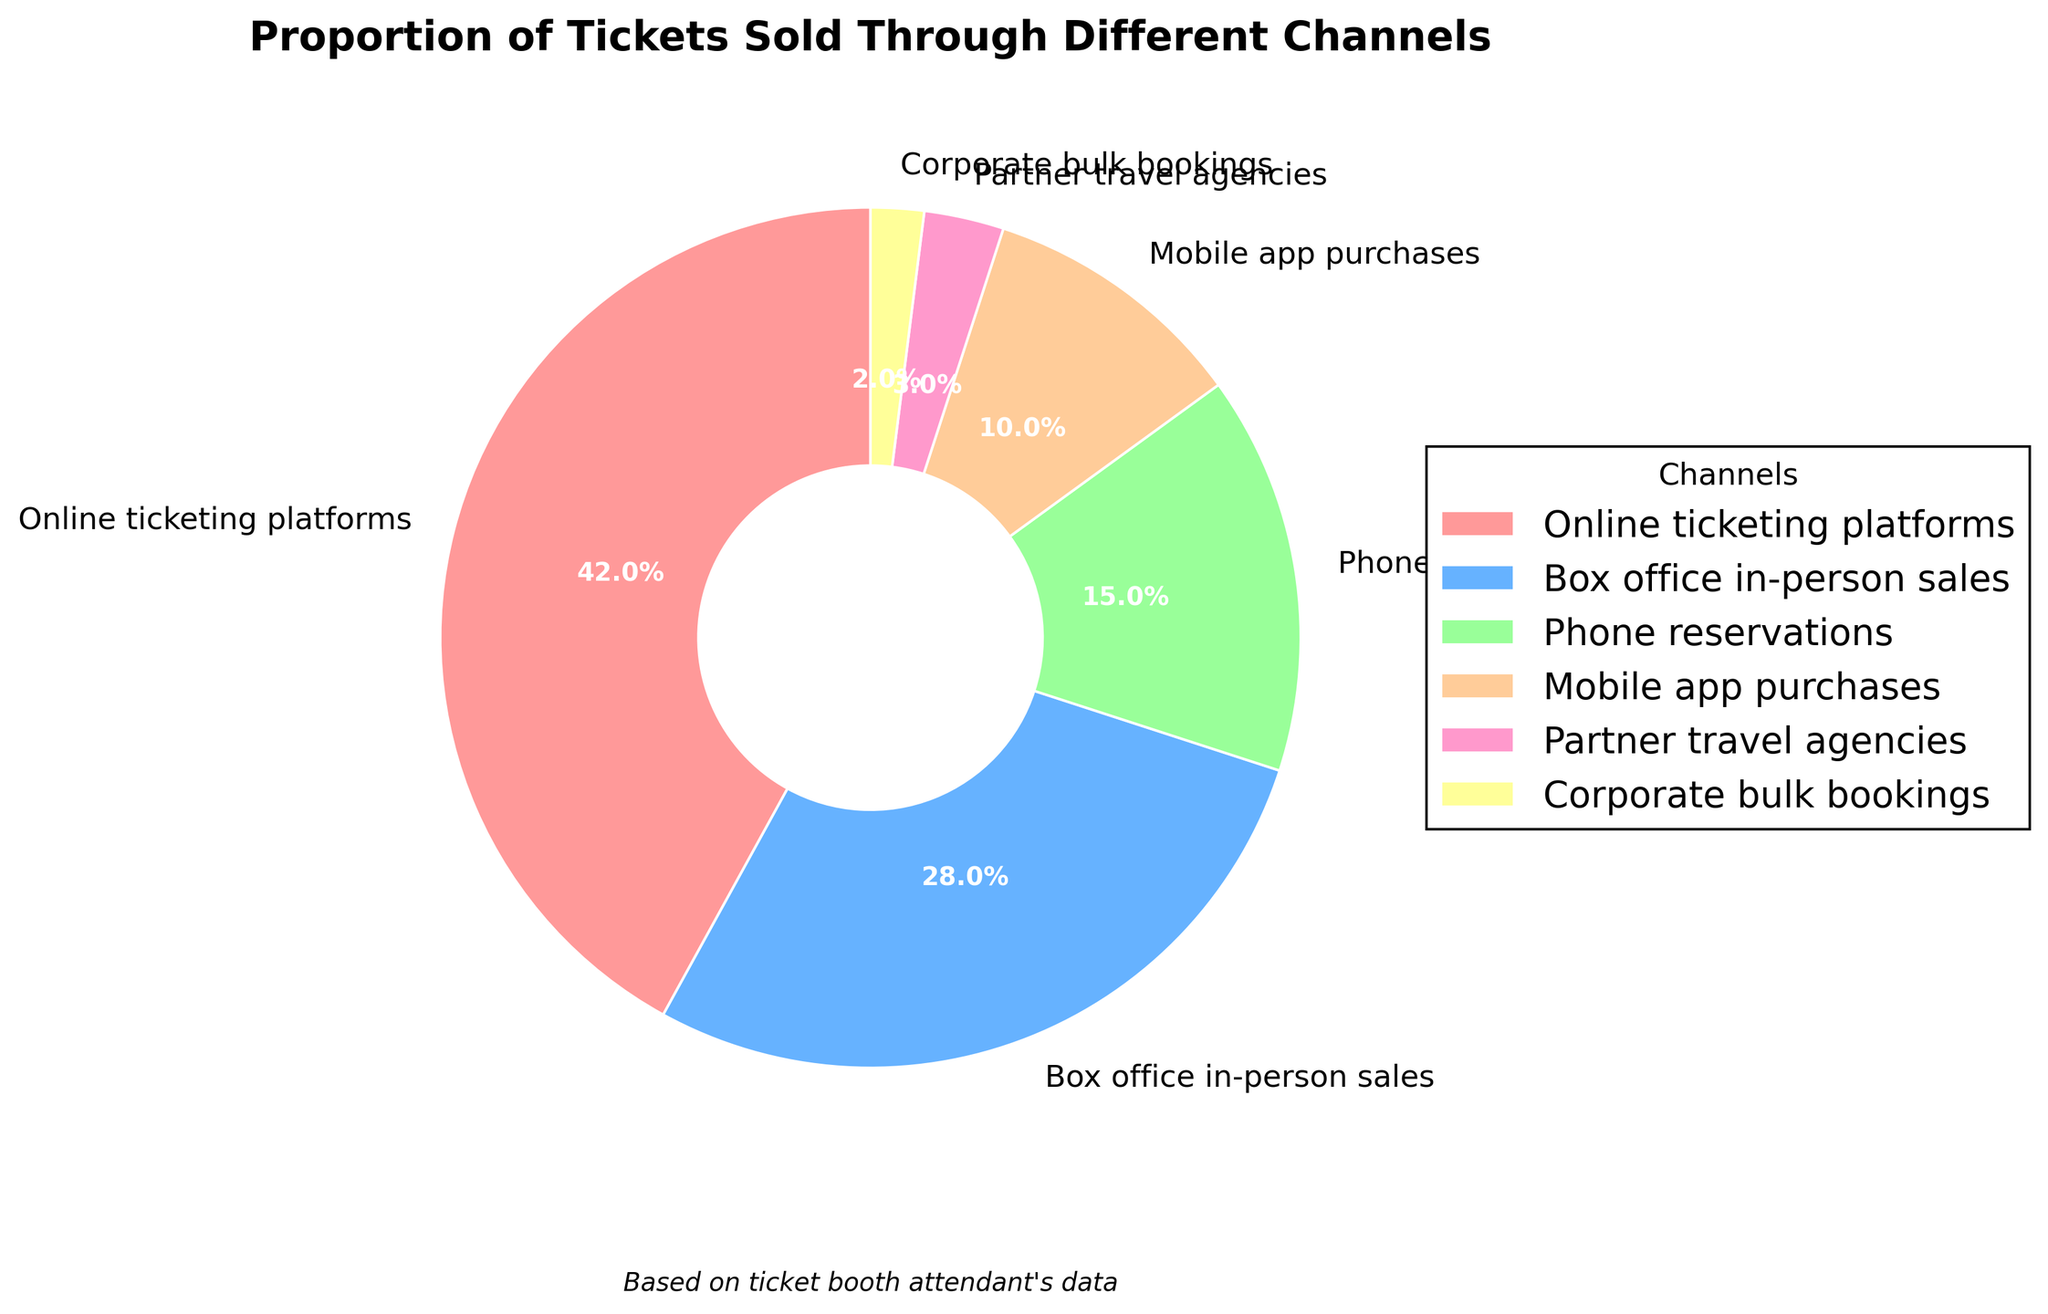Which channel has the highest proportion of tickets sold? From the pie chart, the wedge with the largest size is labeled as "Online ticketing platforms" with a percentage of 42%.
Answer: Online ticketing platforms What is the combined percentage of tickets sold through online and in-person channels? In the pie chart, online ticketing platforms show 42% and box office in-person sales show 28%. Adding these percentages together gives 42% + 28% = 70%.
Answer: 70% Which channels together make up less than 10% of the total tickets sold? Checking each segment from the pie chart, partner travel agencies have 3% and corporate bulk bookings have 2%. Adding them together gives 3% + 2% = 5%, which is less than 10%.
Answer: Partner travel agencies, Corporate bulk bookings How does the proportion of phone reservations compare to that of mobile app purchases? According to the pie chart, phone reservations represent 15% and mobile app purchases represent 10%. Therefore, phone reservations are greater than mobile app purchases by 15% - 10% = 5%.
Answer: Phone reservations are greater by 5% What is the difference in ticket sales proportion between the highest and lowest channels? The highest proportion is for online ticketing platforms at 42%, and the lowest is corporate bulk bookings at 2%. The difference is 42% - 2% = 40%.
Answer: 40% Which channel has the smallest proportion of tickets sold? In the pie chart, the smallest wedge is labeled "Corporate bulk bookings" with a percentage of 2%.
Answer: Corporate bulk bookings What percentage of tickets are sold through channels other than the top two? The top two channels are online ticketing platforms (42%) and box office in-person sales (28%), together accounting for 70%. The total sum of all channels is 100%, so the percentage sold through other channels is 100% - 70% = 30%.
Answer: 30% How does the proportion of mobile app purchases compare visually to other channels? Visually, the mobile app wedge is labeled with 10%, and it is smaller than online platforms (42%) and in-person sales (28%), but larger than partner agencies (3%) and corporate bookings (2%).
Answer: Smaller than online, in-person, and phone; larger than partner and corporate If you add the percentages for all the channels except one, which channel’s value is missing if the total is 85%? If the total for all channels except one is 85%, the missing channel is the one that, when added, will sum to 100%. The remaining percentage is 100% - 85% = 15%, which corresponds to phone reservations.
Answer: Phone reservations 